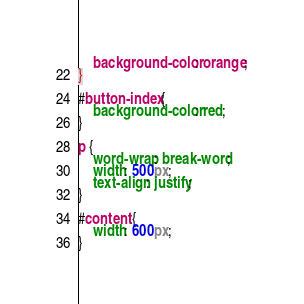Convert code to text. <code><loc_0><loc_0><loc_500><loc_500><_CSS_>    background-color: orange;
}

#button-index {
    background-color: red;
}

p {
    word-wrap: break-word;
    width: 500px;
    text-align: justify;
}

#content {
    width: 600px;
}
</code> 